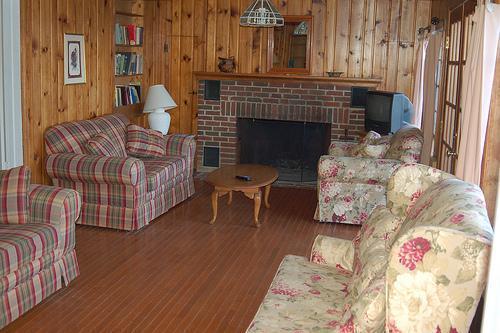How many people are in this photo?
Give a very brief answer. 0. 